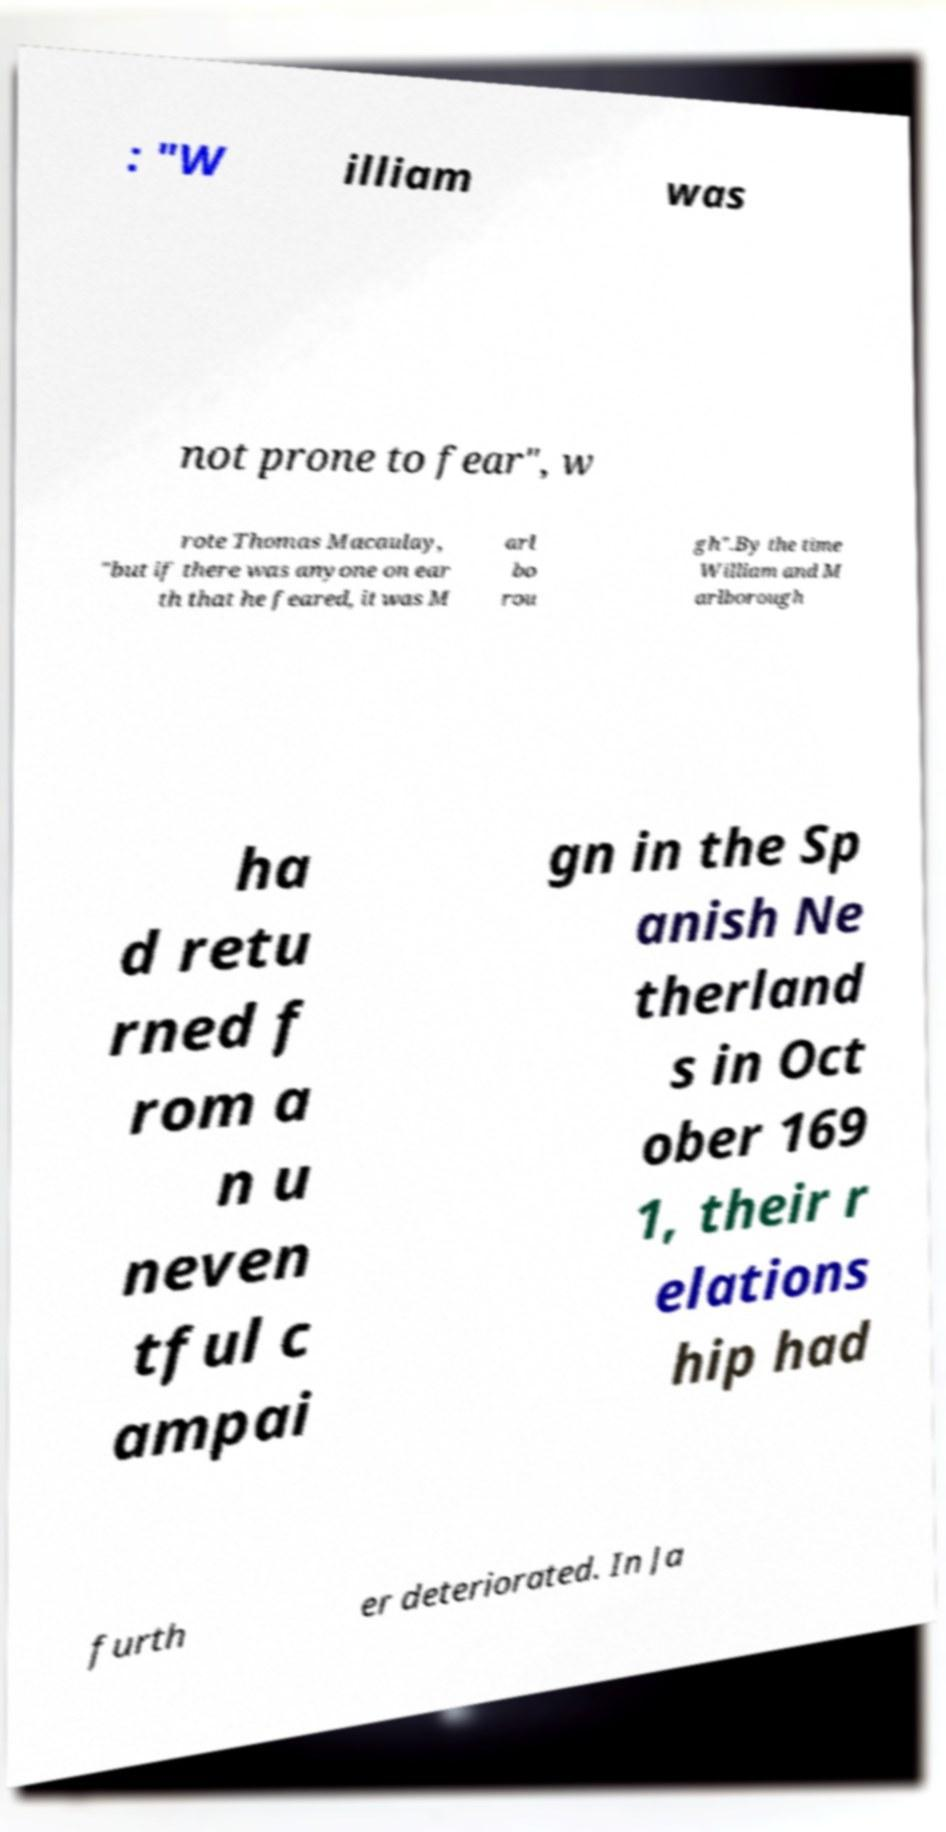Can you accurately transcribe the text from the provided image for me? : "W illiam was not prone to fear", w rote Thomas Macaulay, "but if there was anyone on ear th that he feared, it was M arl bo rou gh".By the time William and M arlborough ha d retu rned f rom a n u neven tful c ampai gn in the Sp anish Ne therland s in Oct ober 169 1, their r elations hip had furth er deteriorated. In Ja 